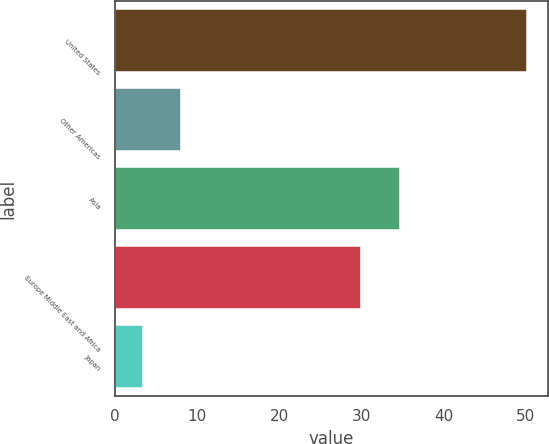Convert chart to OTSL. <chart><loc_0><loc_0><loc_500><loc_500><bar_chart><fcel>United States<fcel>Other Americas<fcel>Asia<fcel>Europe Middle East and Africa<fcel>Japan<nl><fcel>50.2<fcel>8.08<fcel>34.68<fcel>30<fcel>3.4<nl></chart> 